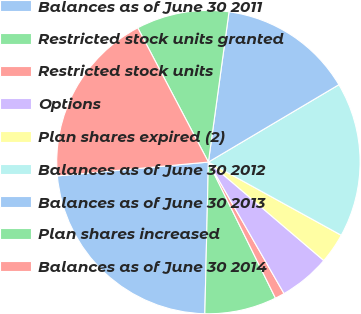<chart> <loc_0><loc_0><loc_500><loc_500><pie_chart><fcel>Balances as of June 30 2011<fcel>Restricted stock units granted<fcel>Restricted stock units<fcel>Options<fcel>Plan shares expired (2)<fcel>Balances as of June 30 2012<fcel>Balances as of June 30 2013<fcel>Plan shares increased<fcel>Balances as of June 30 2014<nl><fcel>23.17%<fcel>7.66%<fcel>1.02%<fcel>5.45%<fcel>3.23%<fcel>16.53%<fcel>14.31%<fcel>9.88%<fcel>18.74%<nl></chart> 